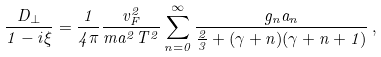Convert formula to latex. <formula><loc_0><loc_0><loc_500><loc_500>\frac { D _ { \bot } } { 1 - i \xi } = \frac { 1 } { 4 \pi } \frac { v _ { F } ^ { 2 } } { m a ^ { 2 } T ^ { 2 } } \sum _ { n = 0 } ^ { \infty } \frac { g _ { n } a _ { n } } { \frac { 2 } { 3 } + ( \gamma + n ) ( \gamma + n + 1 ) } \, ,</formula> 